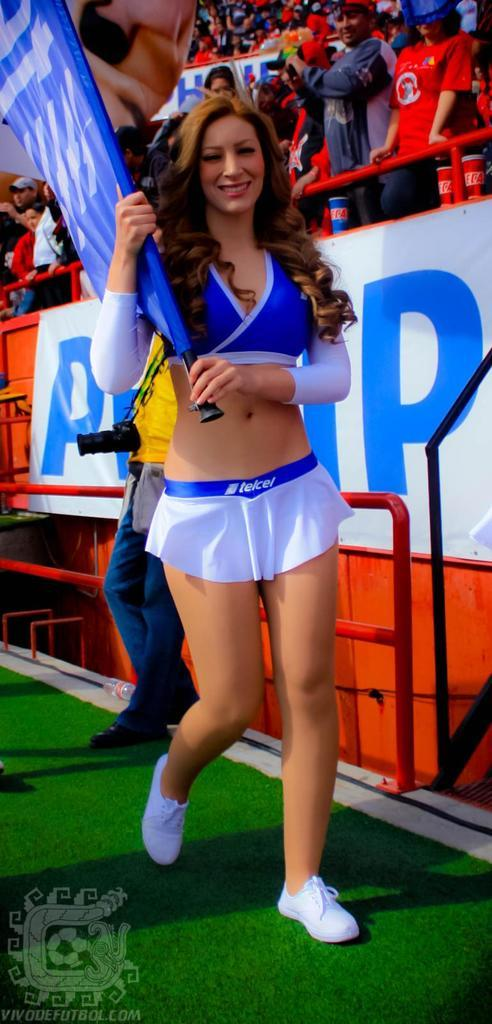<image>
Relay a brief, clear account of the picture shown. A woman is wearing a skirt with telcel on the waistband. 